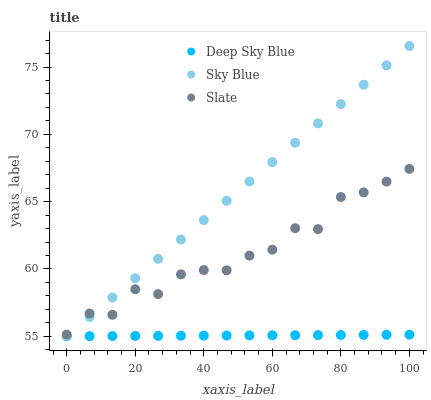Does Deep Sky Blue have the minimum area under the curve?
Answer yes or no. Yes. Does Sky Blue have the maximum area under the curve?
Answer yes or no. Yes. Does Slate have the minimum area under the curve?
Answer yes or no. No. Does Slate have the maximum area under the curve?
Answer yes or no. No. Is Deep Sky Blue the smoothest?
Answer yes or no. Yes. Is Slate the roughest?
Answer yes or no. Yes. Is Slate the smoothest?
Answer yes or no. No. Is Deep Sky Blue the roughest?
Answer yes or no. No. Does Sky Blue have the lowest value?
Answer yes or no. Yes. Does Slate have the lowest value?
Answer yes or no. No. Does Sky Blue have the highest value?
Answer yes or no. Yes. Does Slate have the highest value?
Answer yes or no. No. Is Deep Sky Blue less than Slate?
Answer yes or no. Yes. Is Slate greater than Deep Sky Blue?
Answer yes or no. Yes. Does Sky Blue intersect Deep Sky Blue?
Answer yes or no. Yes. Is Sky Blue less than Deep Sky Blue?
Answer yes or no. No. Is Sky Blue greater than Deep Sky Blue?
Answer yes or no. No. Does Deep Sky Blue intersect Slate?
Answer yes or no. No. 